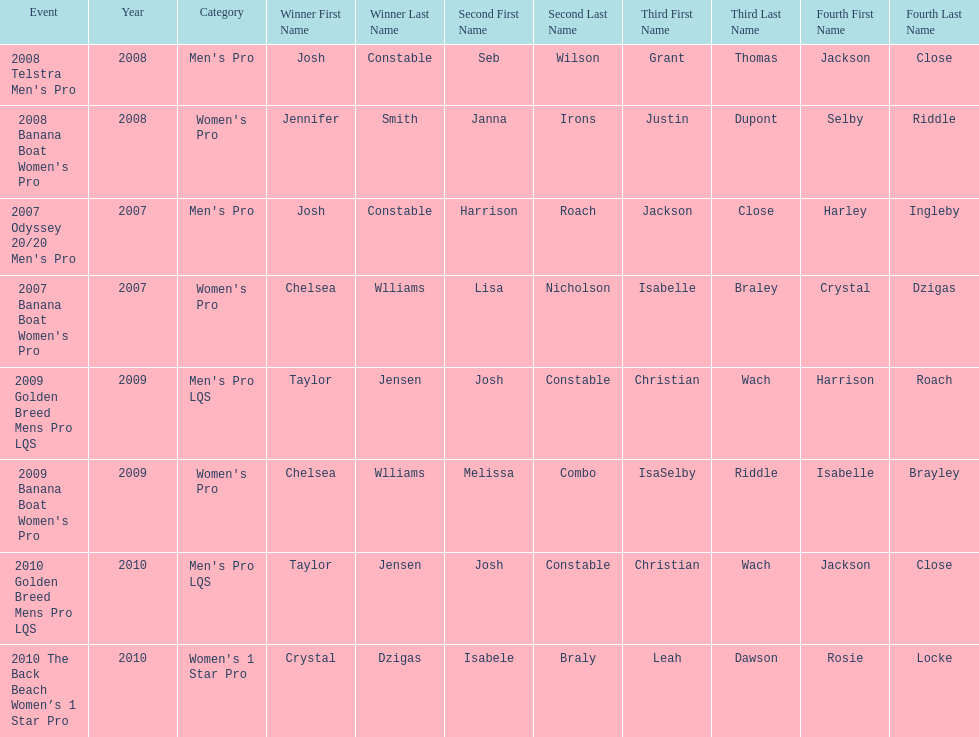Who was the top performer in the 2008 telstra men's pro? Josh Constable. 